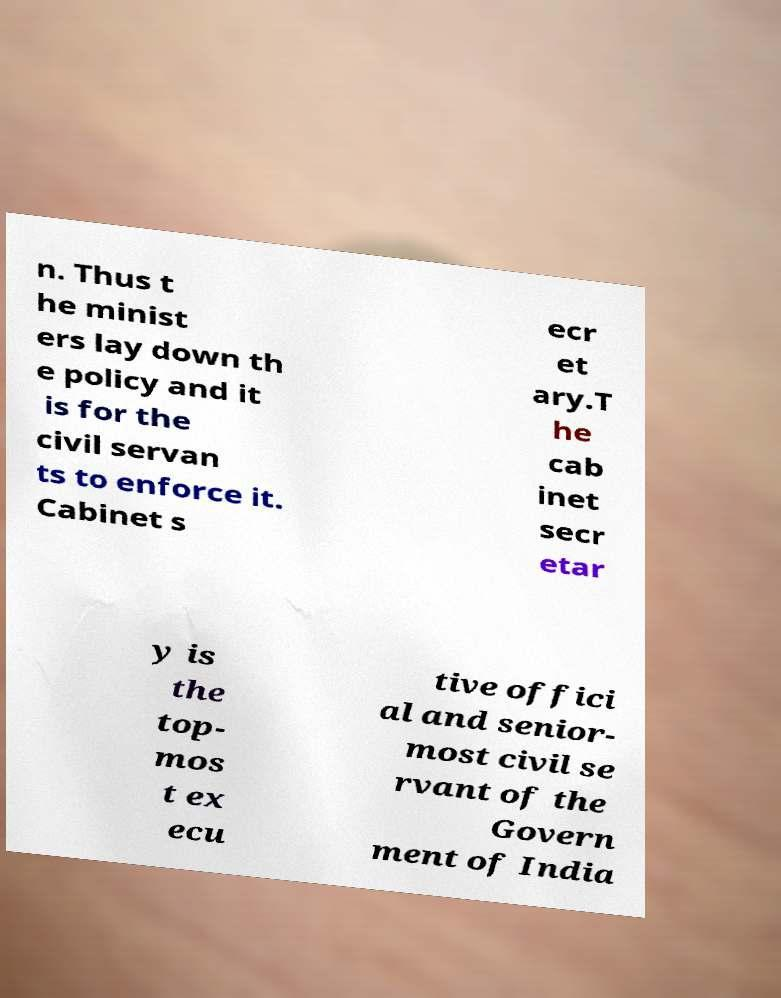Could you extract and type out the text from this image? n. Thus t he minist ers lay down th e policy and it is for the civil servan ts to enforce it. Cabinet s ecr et ary.T he cab inet secr etar y is the top- mos t ex ecu tive offici al and senior- most civil se rvant of the Govern ment of India 